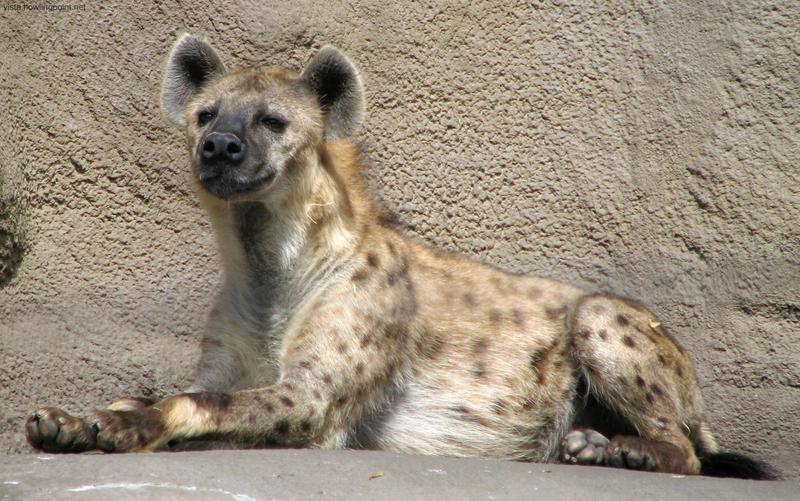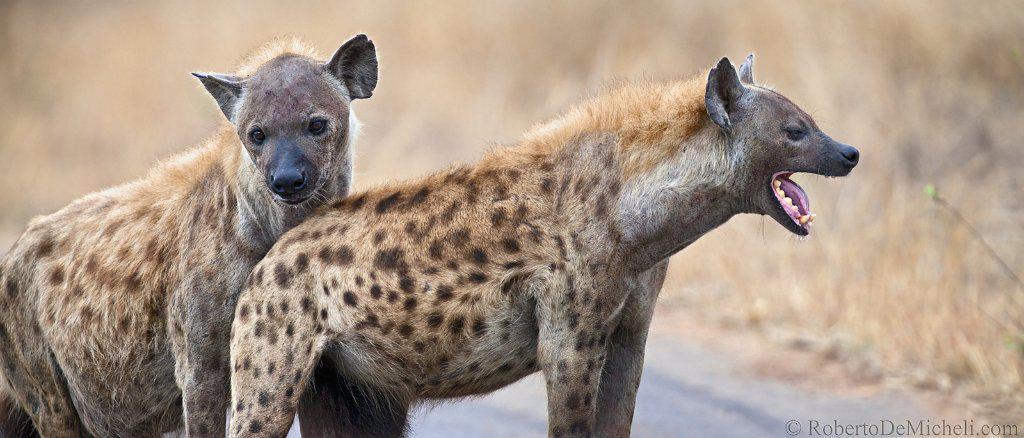The first image is the image on the left, the second image is the image on the right. Assess this claim about the two images: "There are four hyenas in the image pair.". Correct or not? Answer yes or no. No. The first image is the image on the left, the second image is the image on the right. Evaluate the accuracy of this statement regarding the images: "The animal in the image on the left is lying on the ground.". Is it true? Answer yes or no. Yes. 